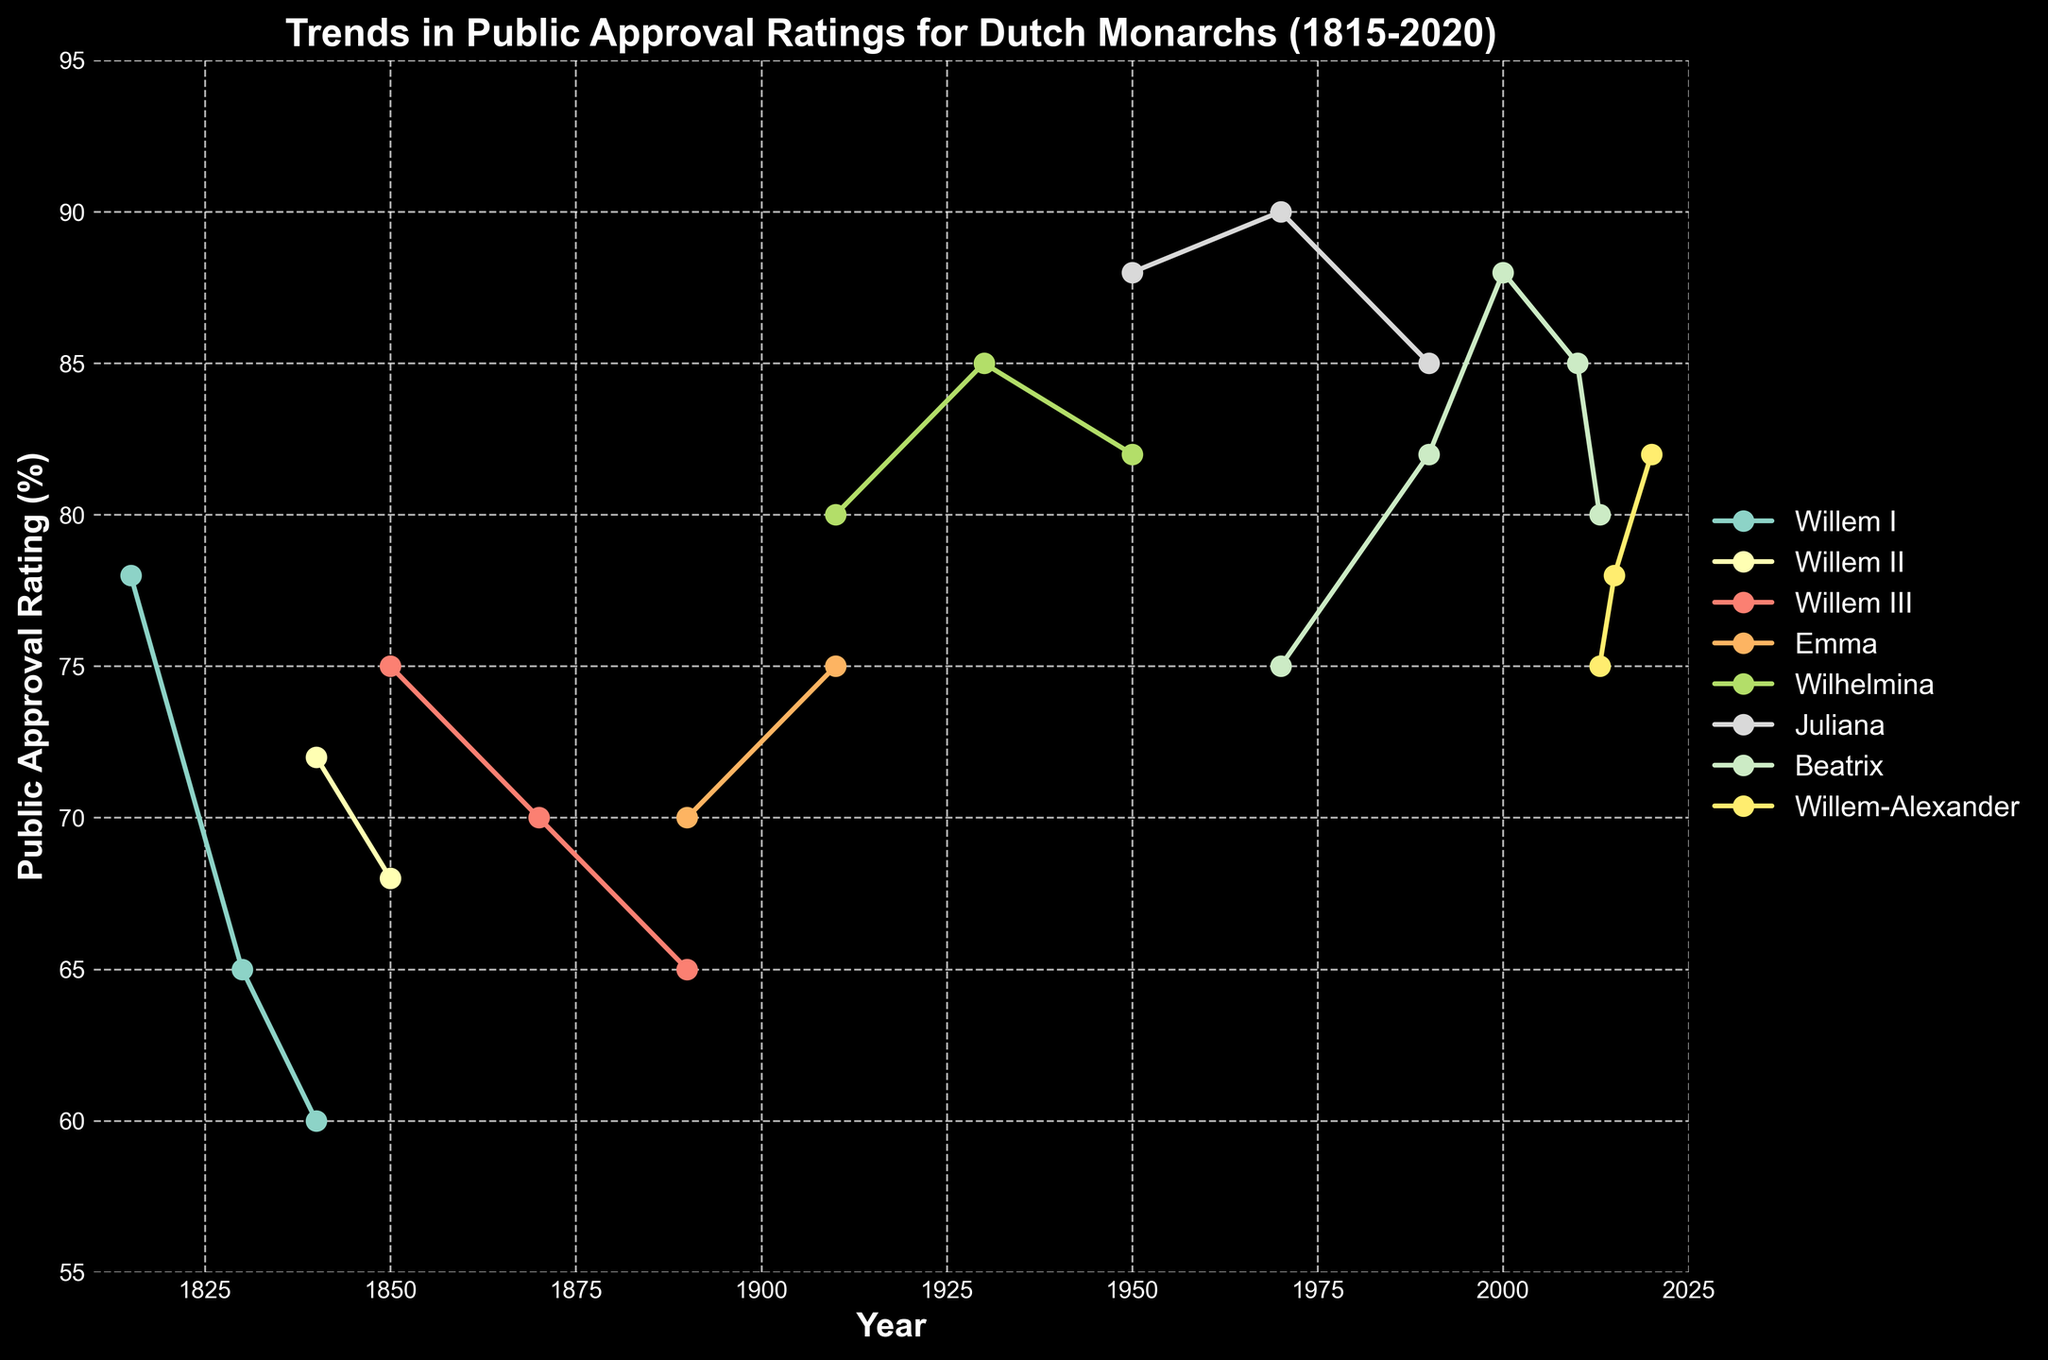What is the highest approval rating for Wilhelmina? Observe the plot line for Wilhelmina; in 1930, it reaches its peak at 85. Therefore, the highest rating is 85.
Answer: 85 Which monarch had the lowest recorded approval rating? Review the plot for each monarch’s line; Willem I has the lowest recorded approval rating in 1830, which is 60.
Answer: Willem I How did public approval ratings change for Willem-Alexander from 2015 to 2020? Look at the trend for Willem-Alexander from 2015 to 2020; his approval rating increased from 78 to 82, showing a positive change.
Answer: Increased Which two monarchs had overlapping approval periods, and how do their approval ratings compare in 1970? Examine the chart for overlapping periods, specifically in 1970; Beatrix (90) and Willem-Alexander (75) overlap. Compare their approval ratings, showing Beatrix had a higher rating.
Answer: Beatrix and Willem-Alexander; Beatrix had a higher rating In which decade did Juliana have the highest public approval rating? Juliana's plot line peaks at 88, which occurs during the 1950s. Therefore, her highest rating is in the 1950s.
Answer: 1950s What is the overall trend of public approval ratings for Dutch monarchs since 1815? Observe the combined trend lines; most monarchs have fluctuating ratings, but there's a general pattern of higher ratings over time, especially from mid-20th century onwards.
Answer: Increasing Who is the monarch with the highest average approval rating based on the data provided? Calculate the average for each monarch: Willem I (69.5), Willem II (70), Willem III (67.5), Emma (72.5), Wilhelmina (85), Juliana (85), Beatrix (84), Willem-Alexander (78.25). Wilhelmina and Juliana have the same highest average (85), but considering Juliana has more available points and overlaps with high ratings, she is taken.
Answer: Juliana Was there any monarch with a decreasing trend throughout their entire recorded period? Examine each monarch's plot line for a continuous decline; Willem III shows a clear downward trend from 75 in 1850 to 65 in 1890.
Answer: Willem III Between Willem I and Willem II, who had a better approval rating in the overlapping year 1840? Look at the plot lines for Willem I and Willem II in 1840; Willem I had 60, and Willem II had 72. Thus, Willem II had a better rating.
Answer: Willem II 